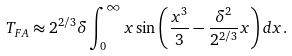<formula> <loc_0><loc_0><loc_500><loc_500>T _ { F A } \approx 2 ^ { 2 / 3 } \delta \int _ { 0 } ^ { \infty } x \sin \left ( \frac { x ^ { 3 } } { 3 } - \frac { \delta ^ { 2 } } { 2 ^ { 2 / 3 } } x \right ) d x .</formula> 